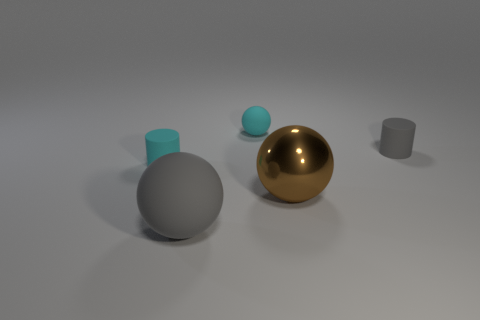The sphere that is both behind the gray matte sphere and in front of the cyan cylinder is made of what material?
Your response must be concise. Metal. What is the material of the other small object that is the same shape as the brown thing?
Keep it short and to the point. Rubber. Is there any other thing that is the same color as the tiny matte sphere?
Ensure brevity in your answer.  Yes. Do the gray sphere and the gray matte object that is right of the large gray rubber ball have the same size?
Your answer should be very brief. No. How many things are either small cylinders to the left of the large gray rubber ball or objects that are right of the cyan ball?
Make the answer very short. 3. There is a rubber thing that is on the right side of the brown object; what color is it?
Your answer should be compact. Gray. Is there a small ball in front of the rubber thing to the right of the brown object?
Provide a short and direct response. No. Is the number of cylinders less than the number of tiny green matte blocks?
Your answer should be very brief. No. What is the cylinder on the right side of the cyan thing in front of the cyan matte ball made of?
Give a very brief answer. Rubber. Does the metallic ball have the same size as the gray ball?
Your answer should be very brief. Yes. 